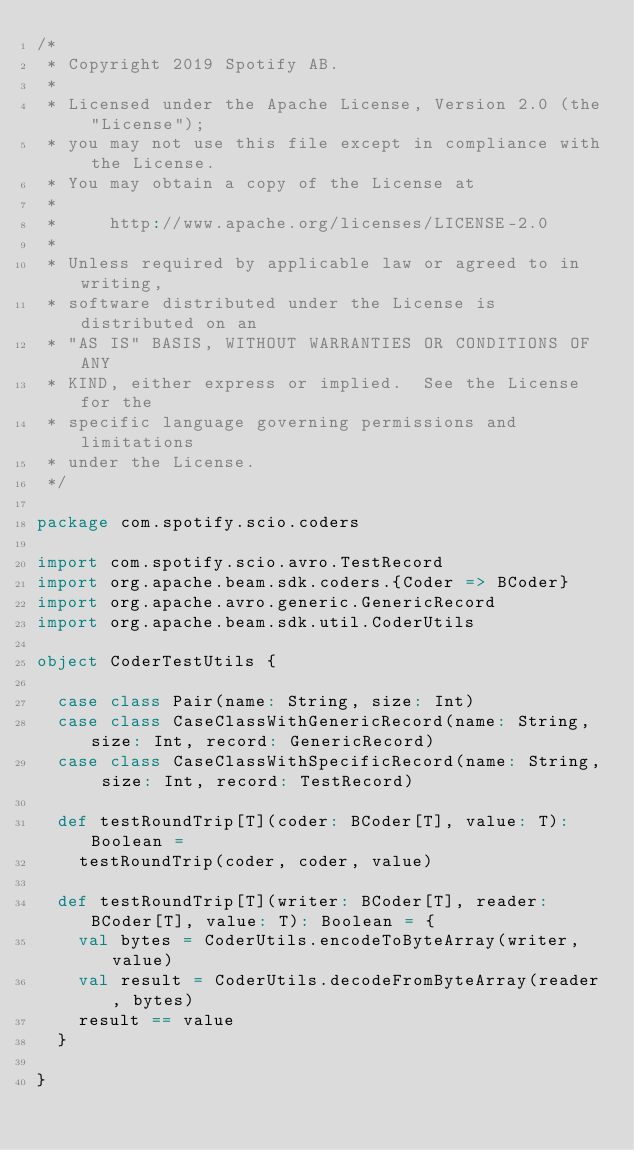Convert code to text. <code><loc_0><loc_0><loc_500><loc_500><_Scala_>/*
 * Copyright 2019 Spotify AB.
 *
 * Licensed under the Apache License, Version 2.0 (the "License");
 * you may not use this file except in compliance with the License.
 * You may obtain a copy of the License at
 *
 *     http://www.apache.org/licenses/LICENSE-2.0
 *
 * Unless required by applicable law or agreed to in writing,
 * software distributed under the License is distributed on an
 * "AS IS" BASIS, WITHOUT WARRANTIES OR CONDITIONS OF ANY
 * KIND, either express or implied.  See the License for the
 * specific language governing permissions and limitations
 * under the License.
 */

package com.spotify.scio.coders

import com.spotify.scio.avro.TestRecord
import org.apache.beam.sdk.coders.{Coder => BCoder}
import org.apache.avro.generic.GenericRecord
import org.apache.beam.sdk.util.CoderUtils

object CoderTestUtils {

  case class Pair(name: String, size: Int)
  case class CaseClassWithGenericRecord(name: String, size: Int, record: GenericRecord)
  case class CaseClassWithSpecificRecord(name: String, size: Int, record: TestRecord)

  def testRoundTrip[T](coder: BCoder[T], value: T): Boolean =
    testRoundTrip(coder, coder, value)

  def testRoundTrip[T](writer: BCoder[T], reader: BCoder[T], value: T): Boolean = {
    val bytes = CoderUtils.encodeToByteArray(writer, value)
    val result = CoderUtils.decodeFromByteArray(reader, bytes)
    result == value
  }

}
</code> 